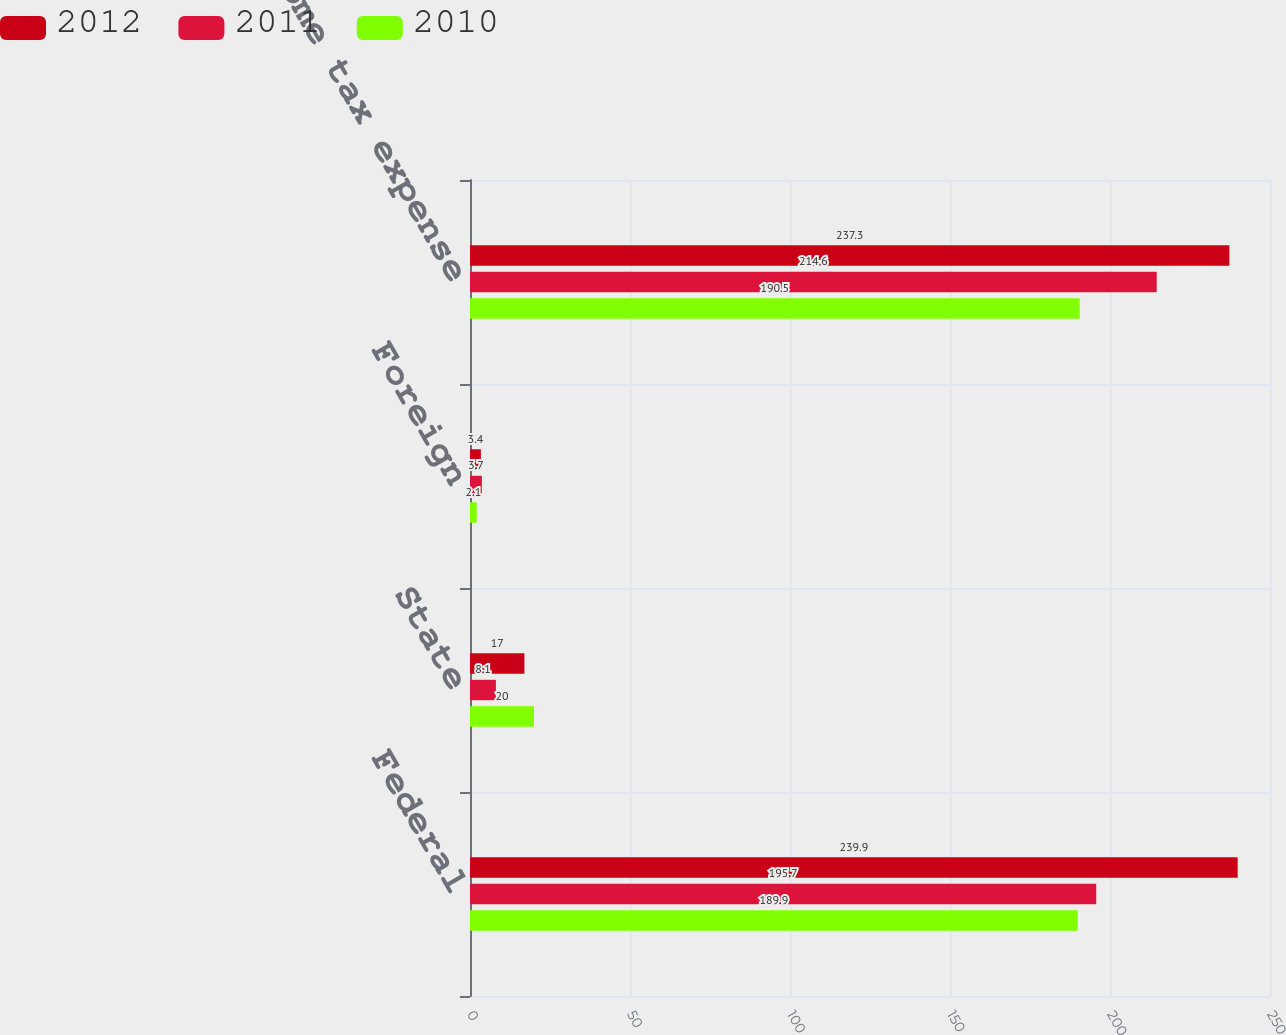Convert chart. <chart><loc_0><loc_0><loc_500><loc_500><stacked_bar_chart><ecel><fcel>Federal<fcel>State<fcel>Foreign<fcel>Total income tax expense<nl><fcel>2012<fcel>239.9<fcel>17<fcel>3.4<fcel>237.3<nl><fcel>2011<fcel>195.7<fcel>8.1<fcel>3.7<fcel>214.6<nl><fcel>2010<fcel>189.9<fcel>20<fcel>2.1<fcel>190.5<nl></chart> 